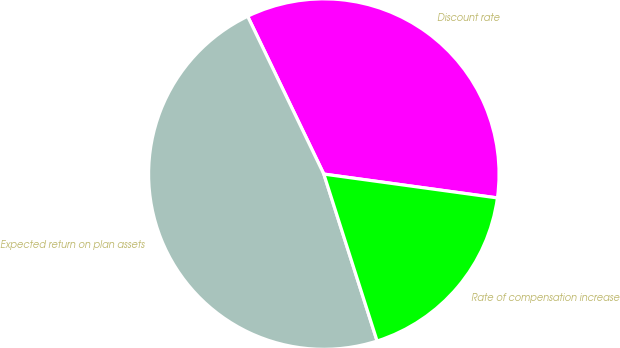Convert chart to OTSL. <chart><loc_0><loc_0><loc_500><loc_500><pie_chart><fcel>Discount rate<fcel>Expected return on plan assets<fcel>Rate of compensation increase<nl><fcel>34.33%<fcel>47.76%<fcel>17.91%<nl></chart> 